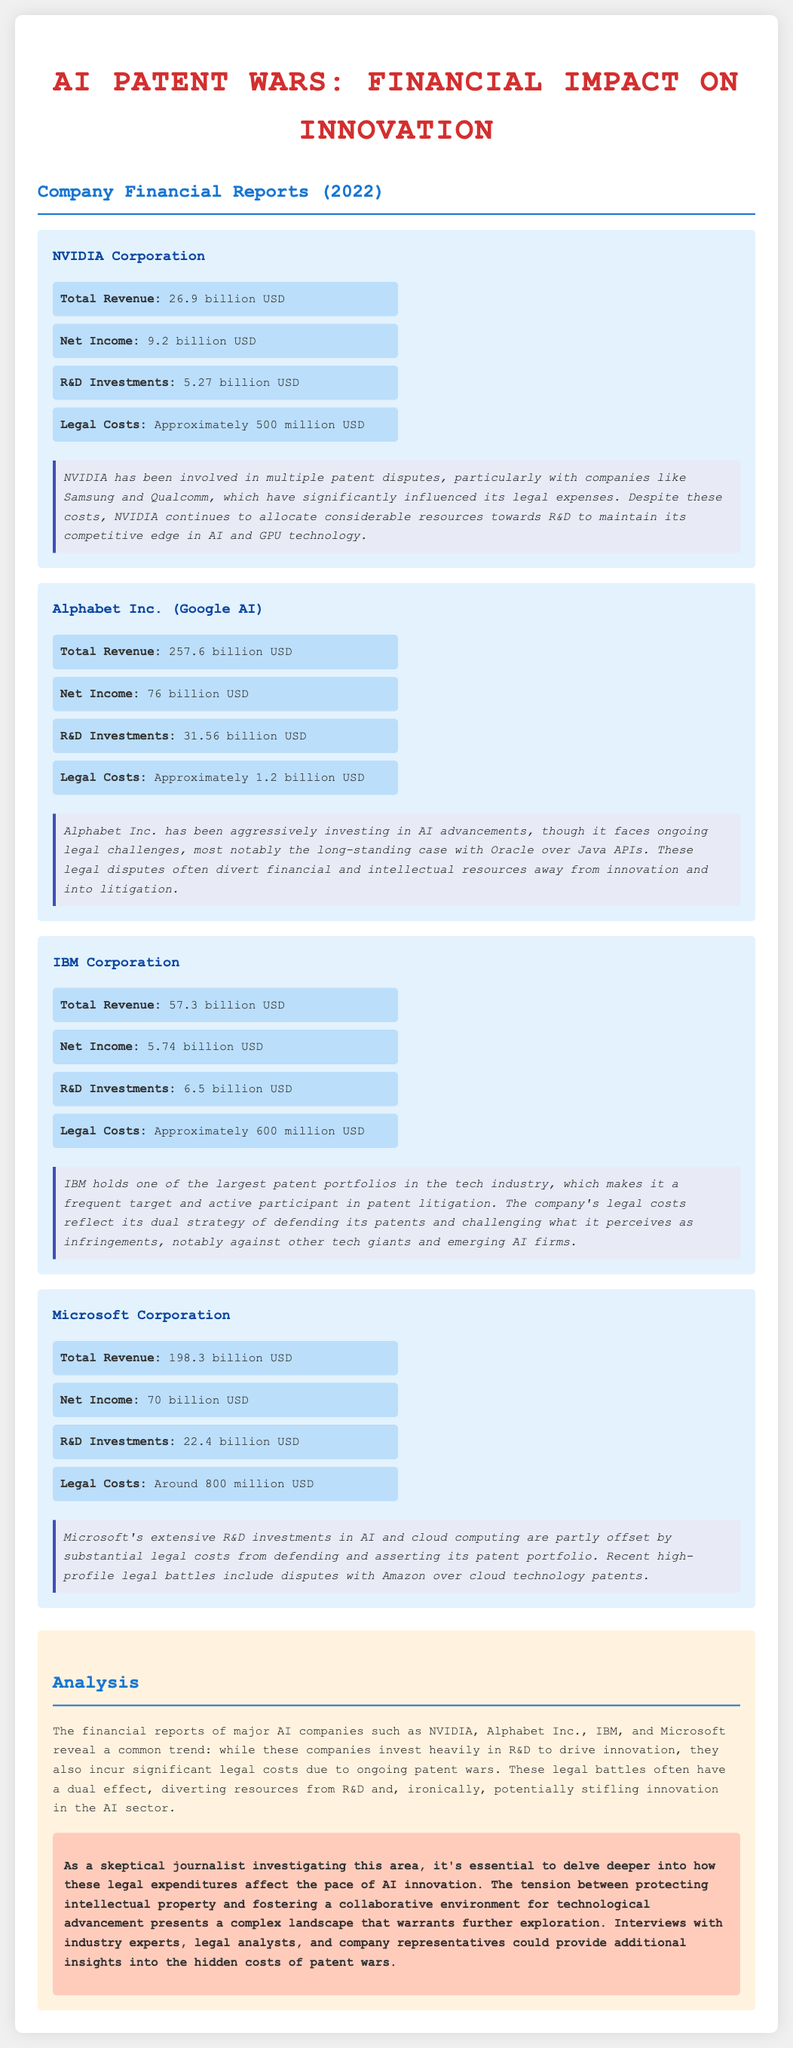What is NVIDIA's total revenue? The total revenue of NVIDIA Corporation in 2022 is specified in the document.
Answer: 26.9 billion USD How much did Alphabet Inc. spend on R&D? The R&D investments for Alphabet Inc. (Google AI) are detailed in the financial report.
Answer: 31.56 billion USD What is IBM’s net income? The net income of IBM Corporation for 2022 is mentioned in the financial report.
Answer: 5.74 billion USD How much did Microsoft incur in legal costs? The document specifies the legal costs associated with Microsoft Corporation for the year 2022.
Answer: Around 800 million USD What notable legal challenge does Alphabet Inc. face? The context regarding Alphabet Inc. identifies a significant legal dispute that affects its resources.
Answer: Oracle over Java APIs Why does NVIDIA continue to invest in R&D despite legal costs? The document explains NVIDIA's strategy amidst patent disputes, highlighting two areas of focus.
Answer: Maintain competitive edge Which company has the highest R&D investment? A comparison of R&D investments across the companies indicates the one with the highest allocation.
Answer: Alphabet Inc. (Google AI) What is a common effect of patent wars on these companies? The analysis section provides insights into the broader impact of legal challenges on innovation.
Answer: Diverting resources from R&D 